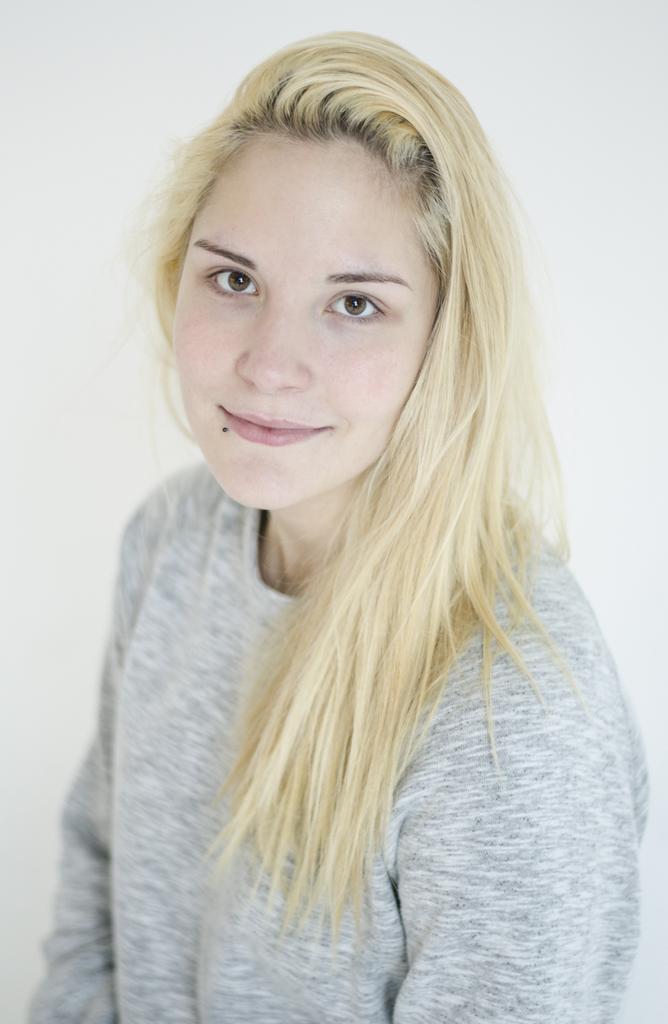Please provide a concise description of this image. In this image I see a woman who is wearing grey color top and I see that it is totally white in the background. 